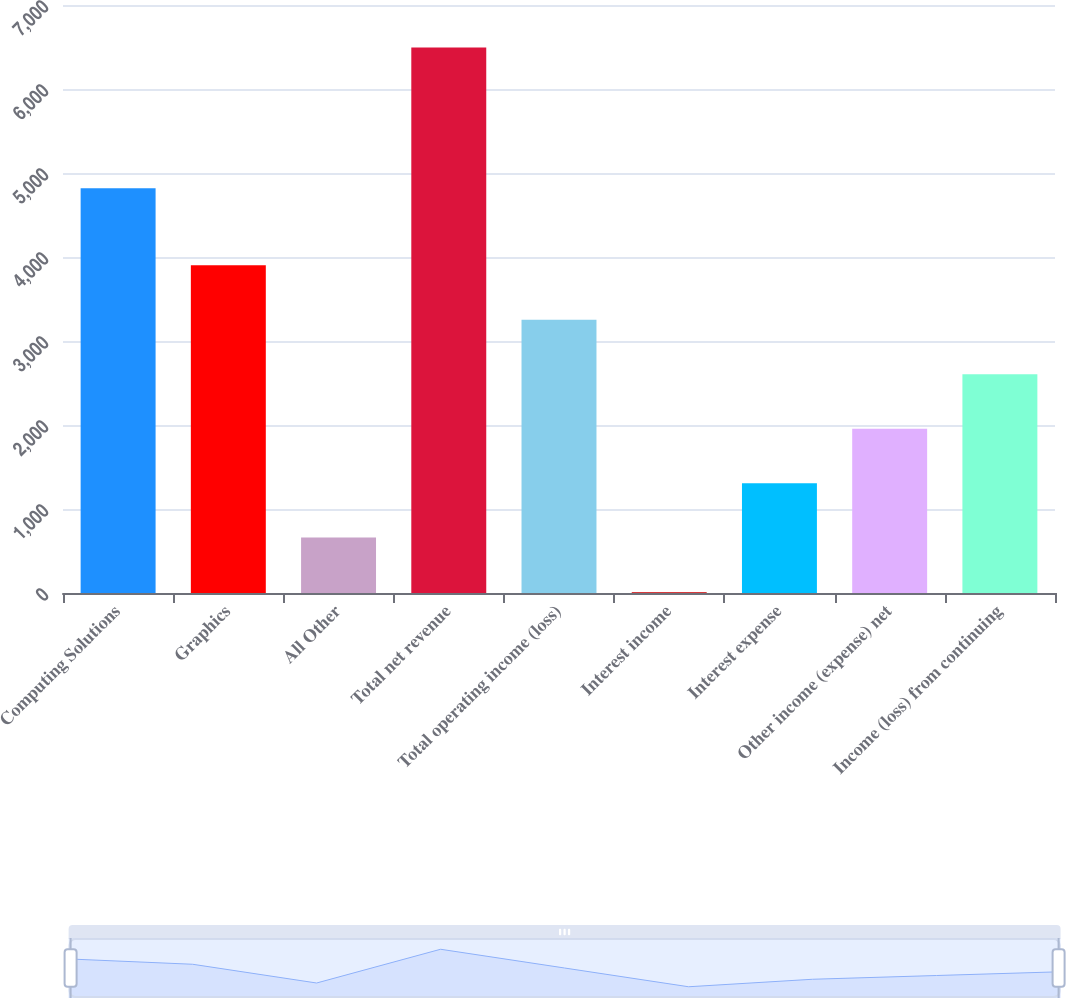Convert chart. <chart><loc_0><loc_0><loc_500><loc_500><bar_chart><fcel>Computing Solutions<fcel>Graphics<fcel>All Other<fcel>Total net revenue<fcel>Total operating income (loss)<fcel>Interest income<fcel>Interest expense<fcel>Other income (expense) net<fcel>Income (loss) from continuing<nl><fcel>4817<fcel>3900.8<fcel>659.3<fcel>6494<fcel>3252.5<fcel>11<fcel>1307.6<fcel>1955.9<fcel>2604.2<nl></chart> 